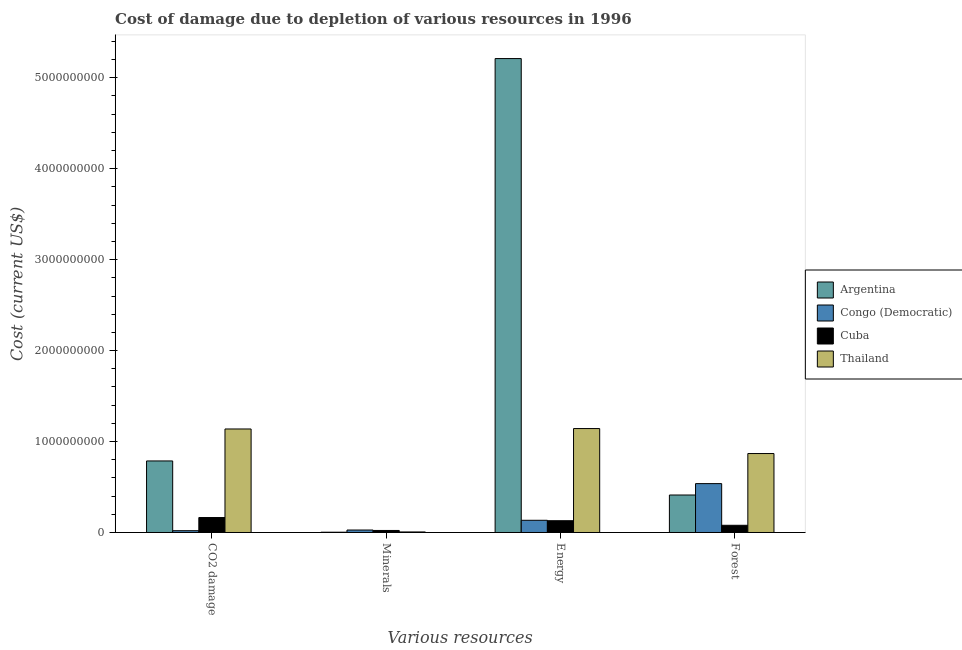How many different coloured bars are there?
Give a very brief answer. 4. How many groups of bars are there?
Provide a succinct answer. 4. What is the label of the 4th group of bars from the left?
Your response must be concise. Forest. What is the cost of damage due to depletion of forests in Argentina?
Your answer should be very brief. 4.12e+08. Across all countries, what is the maximum cost of damage due to depletion of minerals?
Provide a short and direct response. 2.71e+07. Across all countries, what is the minimum cost of damage due to depletion of energy?
Provide a short and direct response. 1.29e+08. In which country was the cost of damage due to depletion of forests maximum?
Your answer should be compact. Thailand. In which country was the cost of damage due to depletion of energy minimum?
Keep it short and to the point. Cuba. What is the total cost of damage due to depletion of energy in the graph?
Make the answer very short. 6.62e+09. What is the difference between the cost of damage due to depletion of minerals in Cuba and that in Congo (Democratic)?
Keep it short and to the point. -4.77e+06. What is the difference between the cost of damage due to depletion of coal in Congo (Democratic) and the cost of damage due to depletion of minerals in Cuba?
Your answer should be very brief. -2.53e+06. What is the average cost of damage due to depletion of minerals per country?
Make the answer very short. 1.46e+07. What is the difference between the cost of damage due to depletion of minerals and cost of damage due to depletion of coal in Argentina?
Offer a very short reply. -7.84e+08. What is the ratio of the cost of damage due to depletion of minerals in Congo (Democratic) to that in Cuba?
Give a very brief answer. 1.21. Is the cost of damage due to depletion of forests in Argentina less than that in Cuba?
Your answer should be very brief. No. What is the difference between the highest and the second highest cost of damage due to depletion of energy?
Ensure brevity in your answer.  4.07e+09. What is the difference between the highest and the lowest cost of damage due to depletion of energy?
Ensure brevity in your answer.  5.08e+09. Is the sum of the cost of damage due to depletion of energy in Thailand and Argentina greater than the maximum cost of damage due to depletion of coal across all countries?
Ensure brevity in your answer.  Yes. What does the 1st bar from the left in CO2 damage represents?
Your response must be concise. Argentina. What does the 1st bar from the right in CO2 damage represents?
Your answer should be very brief. Thailand. How many countries are there in the graph?
Make the answer very short. 4. What is the difference between two consecutive major ticks on the Y-axis?
Keep it short and to the point. 1.00e+09. Are the values on the major ticks of Y-axis written in scientific E-notation?
Make the answer very short. No. Does the graph contain grids?
Offer a terse response. No. What is the title of the graph?
Your answer should be very brief. Cost of damage due to depletion of various resources in 1996 . Does "Slovak Republic" appear as one of the legend labels in the graph?
Ensure brevity in your answer.  No. What is the label or title of the X-axis?
Ensure brevity in your answer.  Various resources. What is the label or title of the Y-axis?
Your response must be concise. Cost (current US$). What is the Cost (current US$) in Argentina in CO2 damage?
Your answer should be compact. 7.87e+08. What is the Cost (current US$) in Congo (Democratic) in CO2 damage?
Provide a short and direct response. 1.98e+07. What is the Cost (current US$) of Cuba in CO2 damage?
Give a very brief answer. 1.64e+08. What is the Cost (current US$) in Thailand in CO2 damage?
Offer a very short reply. 1.14e+09. What is the Cost (current US$) of Argentina in Minerals?
Provide a succinct answer. 3.10e+06. What is the Cost (current US$) of Congo (Democratic) in Minerals?
Keep it short and to the point. 2.71e+07. What is the Cost (current US$) in Cuba in Minerals?
Your answer should be very brief. 2.23e+07. What is the Cost (current US$) of Thailand in Minerals?
Make the answer very short. 5.95e+06. What is the Cost (current US$) in Argentina in Energy?
Make the answer very short. 5.21e+09. What is the Cost (current US$) in Congo (Democratic) in Energy?
Offer a very short reply. 1.34e+08. What is the Cost (current US$) of Cuba in Energy?
Offer a terse response. 1.29e+08. What is the Cost (current US$) in Thailand in Energy?
Your response must be concise. 1.14e+09. What is the Cost (current US$) of Argentina in Forest?
Give a very brief answer. 4.12e+08. What is the Cost (current US$) in Congo (Democratic) in Forest?
Your response must be concise. 5.37e+08. What is the Cost (current US$) in Cuba in Forest?
Your answer should be compact. 7.91e+07. What is the Cost (current US$) of Thailand in Forest?
Make the answer very short. 8.68e+08. Across all Various resources, what is the maximum Cost (current US$) in Argentina?
Your answer should be very brief. 5.21e+09. Across all Various resources, what is the maximum Cost (current US$) in Congo (Democratic)?
Give a very brief answer. 5.37e+08. Across all Various resources, what is the maximum Cost (current US$) in Cuba?
Give a very brief answer. 1.64e+08. Across all Various resources, what is the maximum Cost (current US$) in Thailand?
Your answer should be compact. 1.14e+09. Across all Various resources, what is the minimum Cost (current US$) in Argentina?
Ensure brevity in your answer.  3.10e+06. Across all Various resources, what is the minimum Cost (current US$) of Congo (Democratic)?
Ensure brevity in your answer.  1.98e+07. Across all Various resources, what is the minimum Cost (current US$) of Cuba?
Offer a terse response. 2.23e+07. Across all Various resources, what is the minimum Cost (current US$) in Thailand?
Ensure brevity in your answer.  5.95e+06. What is the total Cost (current US$) of Argentina in the graph?
Provide a succinct answer. 6.41e+09. What is the total Cost (current US$) in Congo (Democratic) in the graph?
Make the answer very short. 7.18e+08. What is the total Cost (current US$) of Cuba in the graph?
Your answer should be very brief. 3.95e+08. What is the total Cost (current US$) of Thailand in the graph?
Give a very brief answer. 3.16e+09. What is the difference between the Cost (current US$) of Argentina in CO2 damage and that in Minerals?
Your answer should be very brief. 7.84e+08. What is the difference between the Cost (current US$) in Congo (Democratic) in CO2 damage and that in Minerals?
Ensure brevity in your answer.  -7.31e+06. What is the difference between the Cost (current US$) of Cuba in CO2 damage and that in Minerals?
Make the answer very short. 1.42e+08. What is the difference between the Cost (current US$) of Thailand in CO2 damage and that in Minerals?
Provide a short and direct response. 1.13e+09. What is the difference between the Cost (current US$) of Argentina in CO2 damage and that in Energy?
Keep it short and to the point. -4.42e+09. What is the difference between the Cost (current US$) of Congo (Democratic) in CO2 damage and that in Energy?
Provide a short and direct response. -1.14e+08. What is the difference between the Cost (current US$) in Cuba in CO2 damage and that in Energy?
Make the answer very short. 3.49e+07. What is the difference between the Cost (current US$) of Thailand in CO2 damage and that in Energy?
Ensure brevity in your answer.  -4.58e+06. What is the difference between the Cost (current US$) of Argentina in CO2 damage and that in Forest?
Provide a succinct answer. 3.75e+08. What is the difference between the Cost (current US$) in Congo (Democratic) in CO2 damage and that in Forest?
Ensure brevity in your answer.  -5.18e+08. What is the difference between the Cost (current US$) of Cuba in CO2 damage and that in Forest?
Keep it short and to the point. 8.52e+07. What is the difference between the Cost (current US$) of Thailand in CO2 damage and that in Forest?
Your response must be concise. 2.70e+08. What is the difference between the Cost (current US$) of Argentina in Minerals and that in Energy?
Your answer should be compact. -5.21e+09. What is the difference between the Cost (current US$) of Congo (Democratic) in Minerals and that in Energy?
Provide a short and direct response. -1.07e+08. What is the difference between the Cost (current US$) in Cuba in Minerals and that in Energy?
Provide a succinct answer. -1.07e+08. What is the difference between the Cost (current US$) of Thailand in Minerals and that in Energy?
Give a very brief answer. -1.14e+09. What is the difference between the Cost (current US$) of Argentina in Minerals and that in Forest?
Provide a succinct answer. -4.09e+08. What is the difference between the Cost (current US$) of Congo (Democratic) in Minerals and that in Forest?
Make the answer very short. -5.10e+08. What is the difference between the Cost (current US$) of Cuba in Minerals and that in Forest?
Make the answer very short. -5.68e+07. What is the difference between the Cost (current US$) of Thailand in Minerals and that in Forest?
Your answer should be compact. -8.62e+08. What is the difference between the Cost (current US$) of Argentina in Energy and that in Forest?
Provide a short and direct response. 4.80e+09. What is the difference between the Cost (current US$) in Congo (Democratic) in Energy and that in Forest?
Your answer should be very brief. -4.03e+08. What is the difference between the Cost (current US$) of Cuba in Energy and that in Forest?
Keep it short and to the point. 5.03e+07. What is the difference between the Cost (current US$) in Thailand in Energy and that in Forest?
Keep it short and to the point. 2.75e+08. What is the difference between the Cost (current US$) of Argentina in CO2 damage and the Cost (current US$) of Congo (Democratic) in Minerals?
Your answer should be very brief. 7.60e+08. What is the difference between the Cost (current US$) of Argentina in CO2 damage and the Cost (current US$) of Cuba in Minerals?
Provide a short and direct response. 7.64e+08. What is the difference between the Cost (current US$) in Argentina in CO2 damage and the Cost (current US$) in Thailand in Minerals?
Your answer should be compact. 7.81e+08. What is the difference between the Cost (current US$) in Congo (Democratic) in CO2 damage and the Cost (current US$) in Cuba in Minerals?
Ensure brevity in your answer.  -2.53e+06. What is the difference between the Cost (current US$) in Congo (Democratic) in CO2 damage and the Cost (current US$) in Thailand in Minerals?
Your answer should be very brief. 1.38e+07. What is the difference between the Cost (current US$) in Cuba in CO2 damage and the Cost (current US$) in Thailand in Minerals?
Ensure brevity in your answer.  1.58e+08. What is the difference between the Cost (current US$) in Argentina in CO2 damage and the Cost (current US$) in Congo (Democratic) in Energy?
Your response must be concise. 6.53e+08. What is the difference between the Cost (current US$) of Argentina in CO2 damage and the Cost (current US$) of Cuba in Energy?
Ensure brevity in your answer.  6.57e+08. What is the difference between the Cost (current US$) in Argentina in CO2 damage and the Cost (current US$) in Thailand in Energy?
Offer a very short reply. -3.56e+08. What is the difference between the Cost (current US$) of Congo (Democratic) in CO2 damage and the Cost (current US$) of Cuba in Energy?
Your answer should be compact. -1.10e+08. What is the difference between the Cost (current US$) of Congo (Democratic) in CO2 damage and the Cost (current US$) of Thailand in Energy?
Provide a succinct answer. -1.12e+09. What is the difference between the Cost (current US$) of Cuba in CO2 damage and the Cost (current US$) of Thailand in Energy?
Provide a short and direct response. -9.78e+08. What is the difference between the Cost (current US$) in Argentina in CO2 damage and the Cost (current US$) in Congo (Democratic) in Forest?
Offer a terse response. 2.49e+08. What is the difference between the Cost (current US$) in Argentina in CO2 damage and the Cost (current US$) in Cuba in Forest?
Make the answer very short. 7.08e+08. What is the difference between the Cost (current US$) of Argentina in CO2 damage and the Cost (current US$) of Thailand in Forest?
Ensure brevity in your answer.  -8.15e+07. What is the difference between the Cost (current US$) of Congo (Democratic) in CO2 damage and the Cost (current US$) of Cuba in Forest?
Make the answer very short. -5.94e+07. What is the difference between the Cost (current US$) in Congo (Democratic) in CO2 damage and the Cost (current US$) in Thailand in Forest?
Your response must be concise. -8.48e+08. What is the difference between the Cost (current US$) in Cuba in CO2 damage and the Cost (current US$) in Thailand in Forest?
Offer a very short reply. -7.04e+08. What is the difference between the Cost (current US$) of Argentina in Minerals and the Cost (current US$) of Congo (Democratic) in Energy?
Provide a succinct answer. -1.31e+08. What is the difference between the Cost (current US$) in Argentina in Minerals and the Cost (current US$) in Cuba in Energy?
Offer a very short reply. -1.26e+08. What is the difference between the Cost (current US$) of Argentina in Minerals and the Cost (current US$) of Thailand in Energy?
Give a very brief answer. -1.14e+09. What is the difference between the Cost (current US$) of Congo (Democratic) in Minerals and the Cost (current US$) of Cuba in Energy?
Your answer should be very brief. -1.02e+08. What is the difference between the Cost (current US$) of Congo (Democratic) in Minerals and the Cost (current US$) of Thailand in Energy?
Your response must be concise. -1.12e+09. What is the difference between the Cost (current US$) in Cuba in Minerals and the Cost (current US$) in Thailand in Energy?
Your answer should be compact. -1.12e+09. What is the difference between the Cost (current US$) of Argentina in Minerals and the Cost (current US$) of Congo (Democratic) in Forest?
Offer a very short reply. -5.34e+08. What is the difference between the Cost (current US$) in Argentina in Minerals and the Cost (current US$) in Cuba in Forest?
Your response must be concise. -7.60e+07. What is the difference between the Cost (current US$) of Argentina in Minerals and the Cost (current US$) of Thailand in Forest?
Provide a succinct answer. -8.65e+08. What is the difference between the Cost (current US$) of Congo (Democratic) in Minerals and the Cost (current US$) of Cuba in Forest?
Offer a very short reply. -5.21e+07. What is the difference between the Cost (current US$) in Congo (Democratic) in Minerals and the Cost (current US$) in Thailand in Forest?
Offer a terse response. -8.41e+08. What is the difference between the Cost (current US$) in Cuba in Minerals and the Cost (current US$) in Thailand in Forest?
Your answer should be very brief. -8.46e+08. What is the difference between the Cost (current US$) in Argentina in Energy and the Cost (current US$) in Congo (Democratic) in Forest?
Your response must be concise. 4.67e+09. What is the difference between the Cost (current US$) in Argentina in Energy and the Cost (current US$) in Cuba in Forest?
Ensure brevity in your answer.  5.13e+09. What is the difference between the Cost (current US$) of Argentina in Energy and the Cost (current US$) of Thailand in Forest?
Offer a terse response. 4.34e+09. What is the difference between the Cost (current US$) in Congo (Democratic) in Energy and the Cost (current US$) in Cuba in Forest?
Give a very brief answer. 5.49e+07. What is the difference between the Cost (current US$) of Congo (Democratic) in Energy and the Cost (current US$) of Thailand in Forest?
Offer a very short reply. -7.34e+08. What is the difference between the Cost (current US$) of Cuba in Energy and the Cost (current US$) of Thailand in Forest?
Provide a short and direct response. -7.39e+08. What is the average Cost (current US$) of Argentina per Various resources?
Ensure brevity in your answer.  1.60e+09. What is the average Cost (current US$) in Congo (Democratic) per Various resources?
Provide a short and direct response. 1.80e+08. What is the average Cost (current US$) of Cuba per Various resources?
Keep it short and to the point. 9.88e+07. What is the average Cost (current US$) of Thailand per Various resources?
Your answer should be very brief. 7.89e+08. What is the difference between the Cost (current US$) of Argentina and Cost (current US$) of Congo (Democratic) in CO2 damage?
Ensure brevity in your answer.  7.67e+08. What is the difference between the Cost (current US$) in Argentina and Cost (current US$) in Cuba in CO2 damage?
Your answer should be compact. 6.22e+08. What is the difference between the Cost (current US$) of Argentina and Cost (current US$) of Thailand in CO2 damage?
Make the answer very short. -3.52e+08. What is the difference between the Cost (current US$) of Congo (Democratic) and Cost (current US$) of Cuba in CO2 damage?
Make the answer very short. -1.45e+08. What is the difference between the Cost (current US$) of Congo (Democratic) and Cost (current US$) of Thailand in CO2 damage?
Your answer should be very brief. -1.12e+09. What is the difference between the Cost (current US$) in Cuba and Cost (current US$) in Thailand in CO2 damage?
Ensure brevity in your answer.  -9.74e+08. What is the difference between the Cost (current US$) in Argentina and Cost (current US$) in Congo (Democratic) in Minerals?
Your answer should be compact. -2.40e+07. What is the difference between the Cost (current US$) of Argentina and Cost (current US$) of Cuba in Minerals?
Your answer should be very brief. -1.92e+07. What is the difference between the Cost (current US$) of Argentina and Cost (current US$) of Thailand in Minerals?
Your answer should be very brief. -2.86e+06. What is the difference between the Cost (current US$) of Congo (Democratic) and Cost (current US$) of Cuba in Minerals?
Provide a short and direct response. 4.77e+06. What is the difference between the Cost (current US$) of Congo (Democratic) and Cost (current US$) of Thailand in Minerals?
Provide a succinct answer. 2.11e+07. What is the difference between the Cost (current US$) of Cuba and Cost (current US$) of Thailand in Minerals?
Give a very brief answer. 1.64e+07. What is the difference between the Cost (current US$) of Argentina and Cost (current US$) of Congo (Democratic) in Energy?
Offer a very short reply. 5.08e+09. What is the difference between the Cost (current US$) of Argentina and Cost (current US$) of Cuba in Energy?
Your response must be concise. 5.08e+09. What is the difference between the Cost (current US$) in Argentina and Cost (current US$) in Thailand in Energy?
Your answer should be very brief. 4.07e+09. What is the difference between the Cost (current US$) of Congo (Democratic) and Cost (current US$) of Cuba in Energy?
Offer a terse response. 4.62e+06. What is the difference between the Cost (current US$) of Congo (Democratic) and Cost (current US$) of Thailand in Energy?
Offer a terse response. -1.01e+09. What is the difference between the Cost (current US$) of Cuba and Cost (current US$) of Thailand in Energy?
Offer a very short reply. -1.01e+09. What is the difference between the Cost (current US$) in Argentina and Cost (current US$) in Congo (Democratic) in Forest?
Give a very brief answer. -1.25e+08. What is the difference between the Cost (current US$) of Argentina and Cost (current US$) of Cuba in Forest?
Your answer should be very brief. 3.33e+08. What is the difference between the Cost (current US$) of Argentina and Cost (current US$) of Thailand in Forest?
Your answer should be compact. -4.56e+08. What is the difference between the Cost (current US$) of Congo (Democratic) and Cost (current US$) of Cuba in Forest?
Keep it short and to the point. 4.58e+08. What is the difference between the Cost (current US$) of Congo (Democratic) and Cost (current US$) of Thailand in Forest?
Offer a terse response. -3.31e+08. What is the difference between the Cost (current US$) in Cuba and Cost (current US$) in Thailand in Forest?
Offer a very short reply. -7.89e+08. What is the ratio of the Cost (current US$) in Argentina in CO2 damage to that in Minerals?
Ensure brevity in your answer.  254.14. What is the ratio of the Cost (current US$) of Congo (Democratic) in CO2 damage to that in Minerals?
Provide a short and direct response. 0.73. What is the ratio of the Cost (current US$) of Cuba in CO2 damage to that in Minerals?
Provide a short and direct response. 7.37. What is the ratio of the Cost (current US$) in Thailand in CO2 damage to that in Minerals?
Offer a very short reply. 191.2. What is the ratio of the Cost (current US$) of Argentina in CO2 damage to that in Energy?
Your response must be concise. 0.15. What is the ratio of the Cost (current US$) of Congo (Democratic) in CO2 damage to that in Energy?
Your answer should be compact. 0.15. What is the ratio of the Cost (current US$) in Cuba in CO2 damage to that in Energy?
Ensure brevity in your answer.  1.27. What is the ratio of the Cost (current US$) in Argentina in CO2 damage to that in Forest?
Your response must be concise. 1.91. What is the ratio of the Cost (current US$) of Congo (Democratic) in CO2 damage to that in Forest?
Provide a succinct answer. 0.04. What is the ratio of the Cost (current US$) in Cuba in CO2 damage to that in Forest?
Your response must be concise. 2.08. What is the ratio of the Cost (current US$) of Thailand in CO2 damage to that in Forest?
Give a very brief answer. 1.31. What is the ratio of the Cost (current US$) of Argentina in Minerals to that in Energy?
Offer a terse response. 0. What is the ratio of the Cost (current US$) of Congo (Democratic) in Minerals to that in Energy?
Ensure brevity in your answer.  0.2. What is the ratio of the Cost (current US$) of Cuba in Minerals to that in Energy?
Ensure brevity in your answer.  0.17. What is the ratio of the Cost (current US$) in Thailand in Minerals to that in Energy?
Offer a very short reply. 0.01. What is the ratio of the Cost (current US$) in Argentina in Minerals to that in Forest?
Provide a short and direct response. 0.01. What is the ratio of the Cost (current US$) in Congo (Democratic) in Minerals to that in Forest?
Offer a terse response. 0.05. What is the ratio of the Cost (current US$) of Cuba in Minerals to that in Forest?
Offer a very short reply. 0.28. What is the ratio of the Cost (current US$) in Thailand in Minerals to that in Forest?
Provide a short and direct response. 0.01. What is the ratio of the Cost (current US$) in Argentina in Energy to that in Forest?
Provide a short and direct response. 12.65. What is the ratio of the Cost (current US$) in Congo (Democratic) in Energy to that in Forest?
Ensure brevity in your answer.  0.25. What is the ratio of the Cost (current US$) of Cuba in Energy to that in Forest?
Provide a succinct answer. 1.64. What is the ratio of the Cost (current US$) in Thailand in Energy to that in Forest?
Offer a very short reply. 1.32. What is the difference between the highest and the second highest Cost (current US$) of Argentina?
Provide a short and direct response. 4.42e+09. What is the difference between the highest and the second highest Cost (current US$) of Congo (Democratic)?
Your answer should be very brief. 4.03e+08. What is the difference between the highest and the second highest Cost (current US$) in Cuba?
Keep it short and to the point. 3.49e+07. What is the difference between the highest and the second highest Cost (current US$) in Thailand?
Ensure brevity in your answer.  4.58e+06. What is the difference between the highest and the lowest Cost (current US$) of Argentina?
Your answer should be very brief. 5.21e+09. What is the difference between the highest and the lowest Cost (current US$) in Congo (Democratic)?
Give a very brief answer. 5.18e+08. What is the difference between the highest and the lowest Cost (current US$) in Cuba?
Provide a succinct answer. 1.42e+08. What is the difference between the highest and the lowest Cost (current US$) in Thailand?
Your response must be concise. 1.14e+09. 